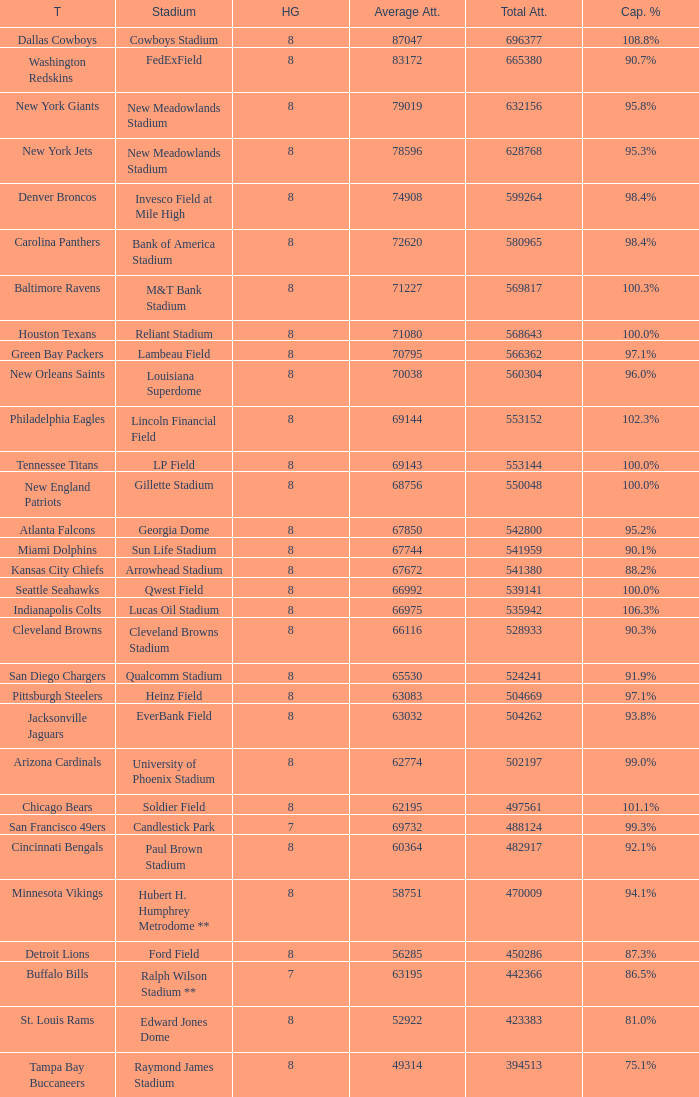What was the total attendance of the New York Giants? 632156.0. 